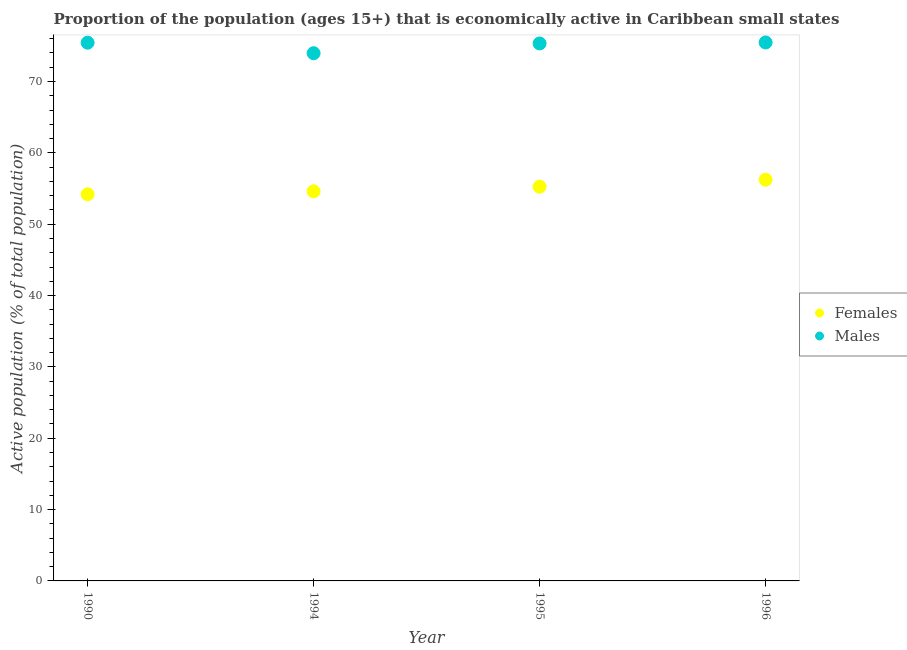What is the percentage of economically active male population in 1995?
Offer a very short reply. 75.34. Across all years, what is the maximum percentage of economically active female population?
Make the answer very short. 56.23. Across all years, what is the minimum percentage of economically active female population?
Your answer should be very brief. 54.19. What is the total percentage of economically active female population in the graph?
Provide a short and direct response. 220.29. What is the difference between the percentage of economically active male population in 1990 and that in 1995?
Give a very brief answer. 0.11. What is the difference between the percentage of economically active male population in 1994 and the percentage of economically active female population in 1995?
Keep it short and to the point. 18.71. What is the average percentage of economically active female population per year?
Offer a terse response. 55.07. In the year 1990, what is the difference between the percentage of economically active female population and percentage of economically active male population?
Your response must be concise. -21.25. What is the ratio of the percentage of economically active female population in 1990 to that in 1995?
Offer a terse response. 0.98. Is the percentage of economically active male population in 1995 less than that in 1996?
Offer a very short reply. Yes. What is the difference between the highest and the second highest percentage of economically active male population?
Your answer should be compact. 0.03. What is the difference between the highest and the lowest percentage of economically active male population?
Your answer should be compact. 1.5. In how many years, is the percentage of economically active female population greater than the average percentage of economically active female population taken over all years?
Your response must be concise. 2. Does the percentage of economically active female population monotonically increase over the years?
Your response must be concise. Yes. Is the percentage of economically active female population strictly less than the percentage of economically active male population over the years?
Offer a terse response. Yes. How many dotlines are there?
Make the answer very short. 2. Are the values on the major ticks of Y-axis written in scientific E-notation?
Provide a succinct answer. No. How many legend labels are there?
Your response must be concise. 2. What is the title of the graph?
Keep it short and to the point. Proportion of the population (ages 15+) that is economically active in Caribbean small states. Does "Quality of trade" appear as one of the legend labels in the graph?
Offer a very short reply. No. What is the label or title of the Y-axis?
Your response must be concise. Active population (% of total population). What is the Active population (% of total population) of Females in 1990?
Offer a terse response. 54.19. What is the Active population (% of total population) of Males in 1990?
Keep it short and to the point. 75.44. What is the Active population (% of total population) in Females in 1994?
Offer a terse response. 54.61. What is the Active population (% of total population) of Males in 1994?
Provide a succinct answer. 73.97. What is the Active population (% of total population) in Females in 1995?
Keep it short and to the point. 55.26. What is the Active population (% of total population) in Males in 1995?
Ensure brevity in your answer.  75.34. What is the Active population (% of total population) of Females in 1996?
Provide a succinct answer. 56.23. What is the Active population (% of total population) in Males in 1996?
Offer a very short reply. 75.47. Across all years, what is the maximum Active population (% of total population) of Females?
Offer a very short reply. 56.23. Across all years, what is the maximum Active population (% of total population) in Males?
Your response must be concise. 75.47. Across all years, what is the minimum Active population (% of total population) of Females?
Ensure brevity in your answer.  54.19. Across all years, what is the minimum Active population (% of total population) in Males?
Your response must be concise. 73.97. What is the total Active population (% of total population) in Females in the graph?
Give a very brief answer. 220.29. What is the total Active population (% of total population) in Males in the graph?
Offer a very short reply. 300.22. What is the difference between the Active population (% of total population) in Females in 1990 and that in 1994?
Offer a very short reply. -0.42. What is the difference between the Active population (% of total population) in Males in 1990 and that in 1994?
Offer a terse response. 1.47. What is the difference between the Active population (% of total population) in Females in 1990 and that in 1995?
Provide a succinct answer. -1.07. What is the difference between the Active population (% of total population) of Males in 1990 and that in 1995?
Keep it short and to the point. 0.11. What is the difference between the Active population (% of total population) in Females in 1990 and that in 1996?
Provide a succinct answer. -2.04. What is the difference between the Active population (% of total population) in Males in 1990 and that in 1996?
Make the answer very short. -0.03. What is the difference between the Active population (% of total population) in Females in 1994 and that in 1995?
Give a very brief answer. -0.65. What is the difference between the Active population (% of total population) of Males in 1994 and that in 1995?
Make the answer very short. -1.37. What is the difference between the Active population (% of total population) in Females in 1994 and that in 1996?
Provide a short and direct response. -1.62. What is the difference between the Active population (% of total population) of Males in 1994 and that in 1996?
Offer a terse response. -1.5. What is the difference between the Active population (% of total population) of Females in 1995 and that in 1996?
Make the answer very short. -0.98. What is the difference between the Active population (% of total population) in Males in 1995 and that in 1996?
Provide a succinct answer. -0.14. What is the difference between the Active population (% of total population) in Females in 1990 and the Active population (% of total population) in Males in 1994?
Keep it short and to the point. -19.78. What is the difference between the Active population (% of total population) of Females in 1990 and the Active population (% of total population) of Males in 1995?
Offer a terse response. -21.14. What is the difference between the Active population (% of total population) in Females in 1990 and the Active population (% of total population) in Males in 1996?
Provide a short and direct response. -21.28. What is the difference between the Active population (% of total population) in Females in 1994 and the Active population (% of total population) in Males in 1995?
Provide a short and direct response. -20.73. What is the difference between the Active population (% of total population) in Females in 1994 and the Active population (% of total population) in Males in 1996?
Provide a short and direct response. -20.86. What is the difference between the Active population (% of total population) of Females in 1995 and the Active population (% of total population) of Males in 1996?
Make the answer very short. -20.22. What is the average Active population (% of total population) in Females per year?
Offer a very short reply. 55.07. What is the average Active population (% of total population) of Males per year?
Provide a short and direct response. 75.05. In the year 1990, what is the difference between the Active population (% of total population) of Females and Active population (% of total population) of Males?
Offer a very short reply. -21.25. In the year 1994, what is the difference between the Active population (% of total population) in Females and Active population (% of total population) in Males?
Offer a terse response. -19.36. In the year 1995, what is the difference between the Active population (% of total population) in Females and Active population (% of total population) in Males?
Offer a very short reply. -20.08. In the year 1996, what is the difference between the Active population (% of total population) of Females and Active population (% of total population) of Males?
Make the answer very short. -19.24. What is the ratio of the Active population (% of total population) of Females in 1990 to that in 1994?
Offer a very short reply. 0.99. What is the ratio of the Active population (% of total population) in Males in 1990 to that in 1994?
Your answer should be very brief. 1.02. What is the ratio of the Active population (% of total population) of Females in 1990 to that in 1995?
Provide a short and direct response. 0.98. What is the ratio of the Active population (% of total population) in Females in 1990 to that in 1996?
Your response must be concise. 0.96. What is the ratio of the Active population (% of total population) in Males in 1990 to that in 1996?
Ensure brevity in your answer.  1. What is the ratio of the Active population (% of total population) in Females in 1994 to that in 1995?
Your answer should be compact. 0.99. What is the ratio of the Active population (% of total population) of Males in 1994 to that in 1995?
Provide a succinct answer. 0.98. What is the ratio of the Active population (% of total population) in Females in 1994 to that in 1996?
Offer a very short reply. 0.97. What is the ratio of the Active population (% of total population) in Males in 1994 to that in 1996?
Make the answer very short. 0.98. What is the ratio of the Active population (% of total population) of Females in 1995 to that in 1996?
Your answer should be very brief. 0.98. What is the ratio of the Active population (% of total population) in Males in 1995 to that in 1996?
Your response must be concise. 1. What is the difference between the highest and the second highest Active population (% of total population) in Females?
Your answer should be compact. 0.98. What is the difference between the highest and the second highest Active population (% of total population) of Males?
Provide a succinct answer. 0.03. What is the difference between the highest and the lowest Active population (% of total population) in Females?
Your response must be concise. 2.04. What is the difference between the highest and the lowest Active population (% of total population) in Males?
Offer a terse response. 1.5. 